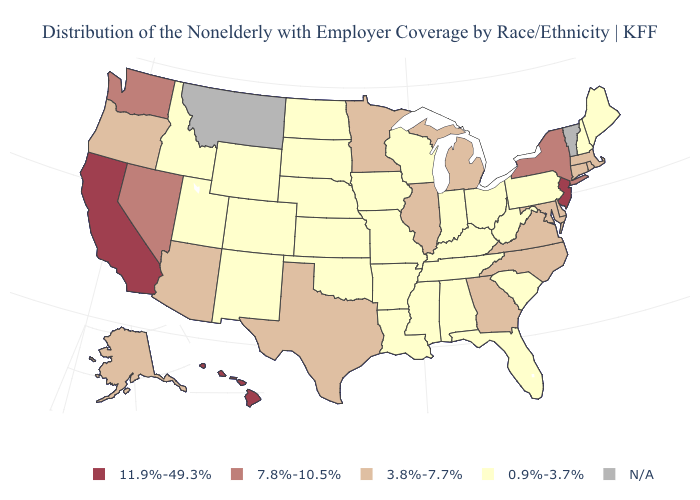Among the states that border Virginia , does West Virginia have the lowest value?
Keep it brief. Yes. What is the value of Minnesota?
Short answer required. 3.8%-7.7%. Does Hawaii have the highest value in the USA?
Short answer required. Yes. Name the states that have a value in the range 7.8%-10.5%?
Write a very short answer. Nevada, New York, Washington. What is the value of Pennsylvania?
Be succinct. 0.9%-3.7%. What is the lowest value in the USA?
Answer briefly. 0.9%-3.7%. Does the map have missing data?
Keep it brief. Yes. Name the states that have a value in the range 3.8%-7.7%?
Concise answer only. Alaska, Arizona, Connecticut, Delaware, Georgia, Illinois, Maryland, Massachusetts, Michigan, Minnesota, North Carolina, Oregon, Rhode Island, Texas, Virginia. What is the value of Louisiana?
Give a very brief answer. 0.9%-3.7%. Does New Jersey have the highest value in the Northeast?
Answer briefly. Yes. Which states hav the highest value in the West?
Quick response, please. California, Hawaii. What is the highest value in the South ?
Write a very short answer. 3.8%-7.7%. Which states have the highest value in the USA?
Quick response, please. California, Hawaii, New Jersey. What is the value of Texas?
Write a very short answer. 3.8%-7.7%. What is the value of Oklahoma?
Be succinct. 0.9%-3.7%. 